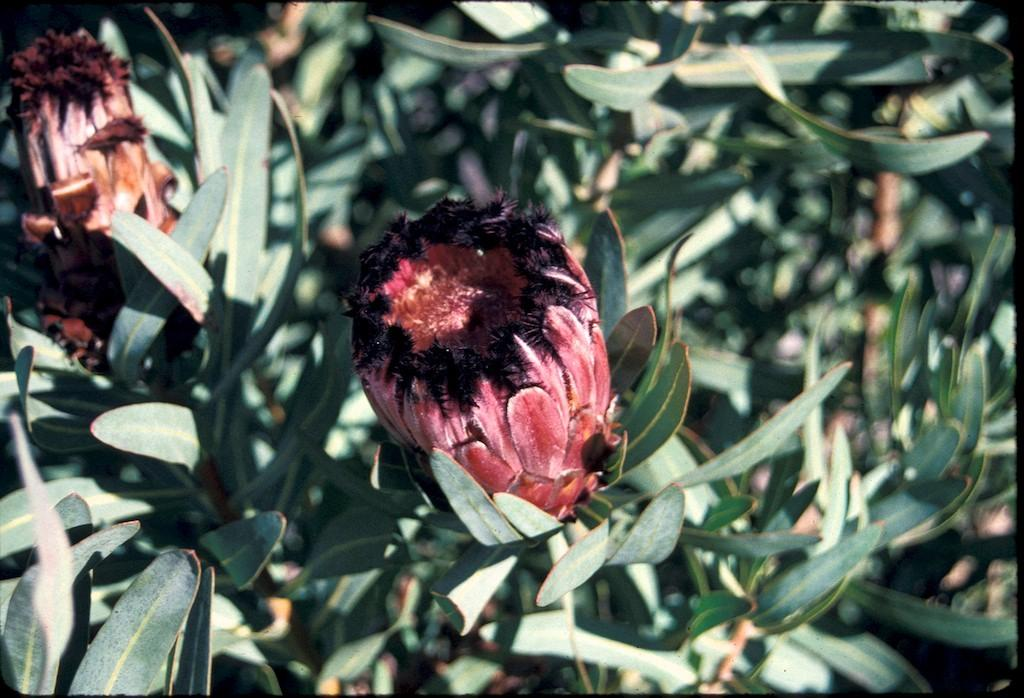How many flowers are visible in the image? There are two flowers in the image. What are the flowers attached to? The flowers are attached to plants. What other parts of the plants can be seen in the image? There are leaves in the image. What type of pies are being served at the club during the trip in the image? There is no mention of pies, a club, or a trip in the image; it only features two flowers attached to plants with leaves. 